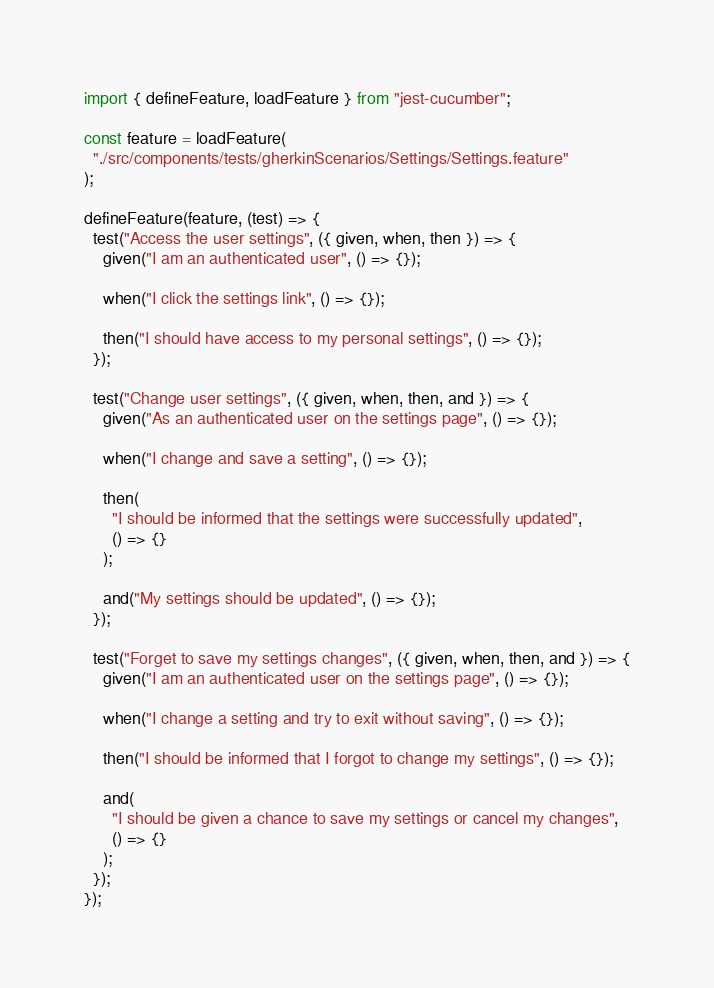<code> <loc_0><loc_0><loc_500><loc_500><_JavaScript_>import { defineFeature, loadFeature } from "jest-cucumber";

const feature = loadFeature(
  "./src/components/tests/gherkinScenarios/Settings/Settings.feature"
);

defineFeature(feature, (test) => {
  test("Access the user settings", ({ given, when, then }) => {
    given("I am an authenticated user", () => {});

    when("I click the settings link", () => {});

    then("I should have access to my personal settings", () => {});
  });

  test("Change user settings", ({ given, when, then, and }) => {
    given("As an authenticated user on the settings page", () => {});

    when("I change and save a setting", () => {});

    then(
      "I should be informed that the settings were successfully updated",
      () => {}
    );

    and("My settings should be updated", () => {});
  });

  test("Forget to save my settings changes", ({ given, when, then, and }) => {
    given("I am an authenticated user on the settings page", () => {});

    when("I change a setting and try to exit without saving", () => {});

    then("I should be informed that I forgot to change my settings", () => {});

    and(
      "I should be given a chance to save my settings or cancel my changes",
      () => {}
    );
  });
});
</code> 